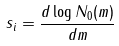<formula> <loc_0><loc_0><loc_500><loc_500>s _ { i } = \frac { d \log N _ { 0 } ( m ) } { d m }</formula> 